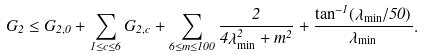<formula> <loc_0><loc_0><loc_500><loc_500>G _ { 2 } \leq G _ { 2 , 0 } + \sum _ { 1 \leq c \leq 6 } G _ { 2 , c } + \sum _ { 6 \leq m \leq 1 0 0 } \frac { 2 } { 4 \lambda _ { \min } ^ { 2 } + m ^ { 2 } } + \frac { \tan ^ { - 1 } ( \lambda _ { \min } / 5 0 ) } { \lambda _ { \min } } .</formula> 